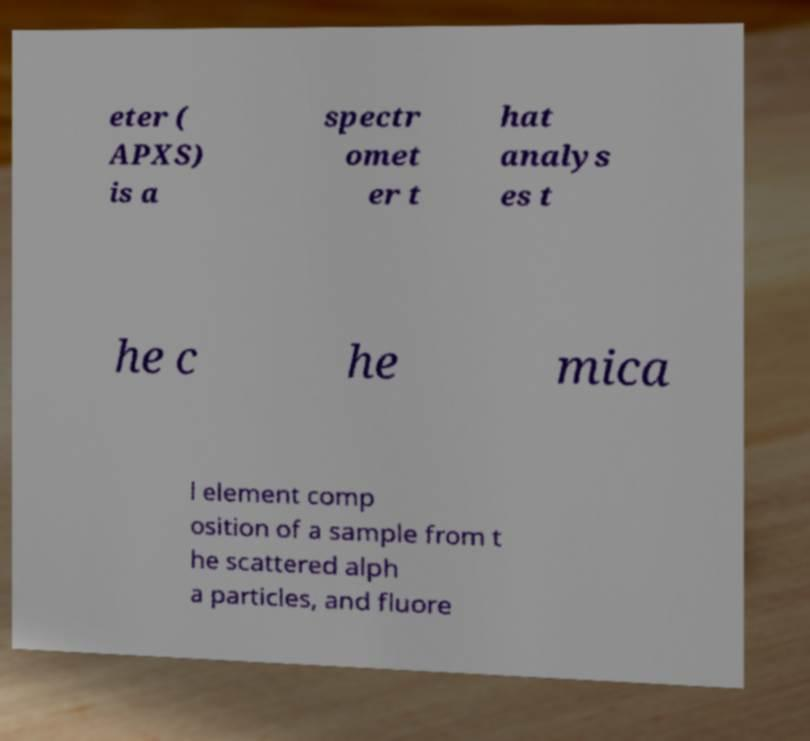Can you read and provide the text displayed in the image?This photo seems to have some interesting text. Can you extract and type it out for me? eter ( APXS) is a spectr omet er t hat analys es t he c he mica l element comp osition of a sample from t he scattered alph a particles, and fluore 